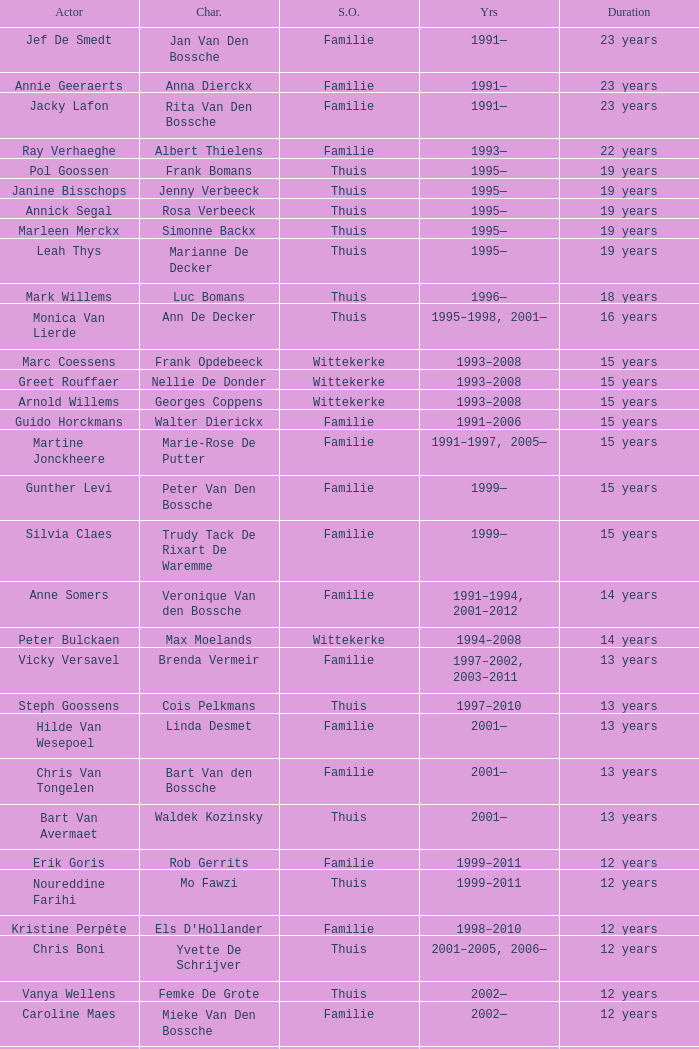In regards to marie-rose de putter, which actor is responsible for playing this character? Martine Jonckheere. 